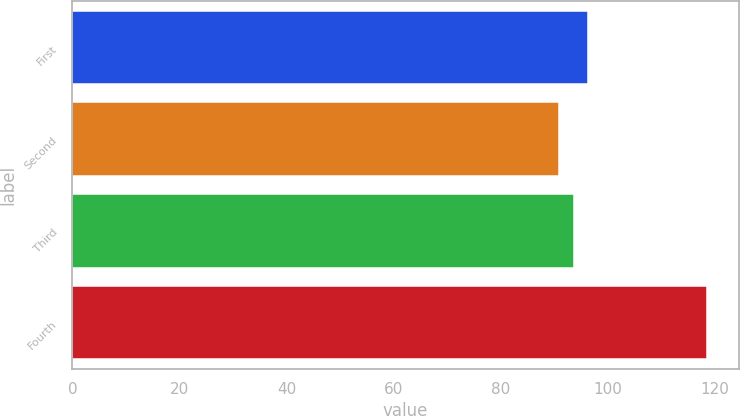Convert chart to OTSL. <chart><loc_0><loc_0><loc_500><loc_500><bar_chart><fcel>First<fcel>Second<fcel>Third<fcel>Fourth<nl><fcel>96.39<fcel>90.85<fcel>93.62<fcel>118.57<nl></chart> 